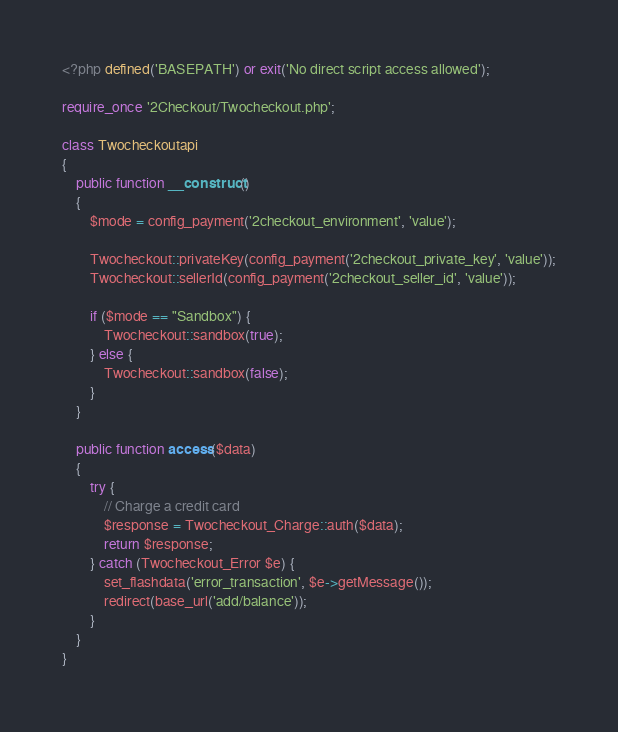<code> <loc_0><loc_0><loc_500><loc_500><_PHP_><?php defined('BASEPATH') or exit('No direct script access allowed');

require_once '2Checkout/Twocheckout.php';

class Twocheckoutapi
{
    public function __construct()
    {
        $mode = config_payment('2checkout_environment', 'value');

        Twocheckout::privateKey(config_payment('2checkout_private_key', 'value'));
        Twocheckout::sellerId(config_payment('2checkout_seller_id', 'value'));

        if ($mode == "Sandbox") {
            Twocheckout::sandbox(true);
        } else {
            Twocheckout::sandbox(false);
        }
    }

    public function access($data)
    {
        try {
            // Charge a credit card
            $response = Twocheckout_Charge::auth($data);
            return $response;
        } catch (Twocheckout_Error $e) {
            set_flashdata('error_transaction', $e->getMessage());
            redirect(base_url('add/balance'));
        }
    }
}
</code> 